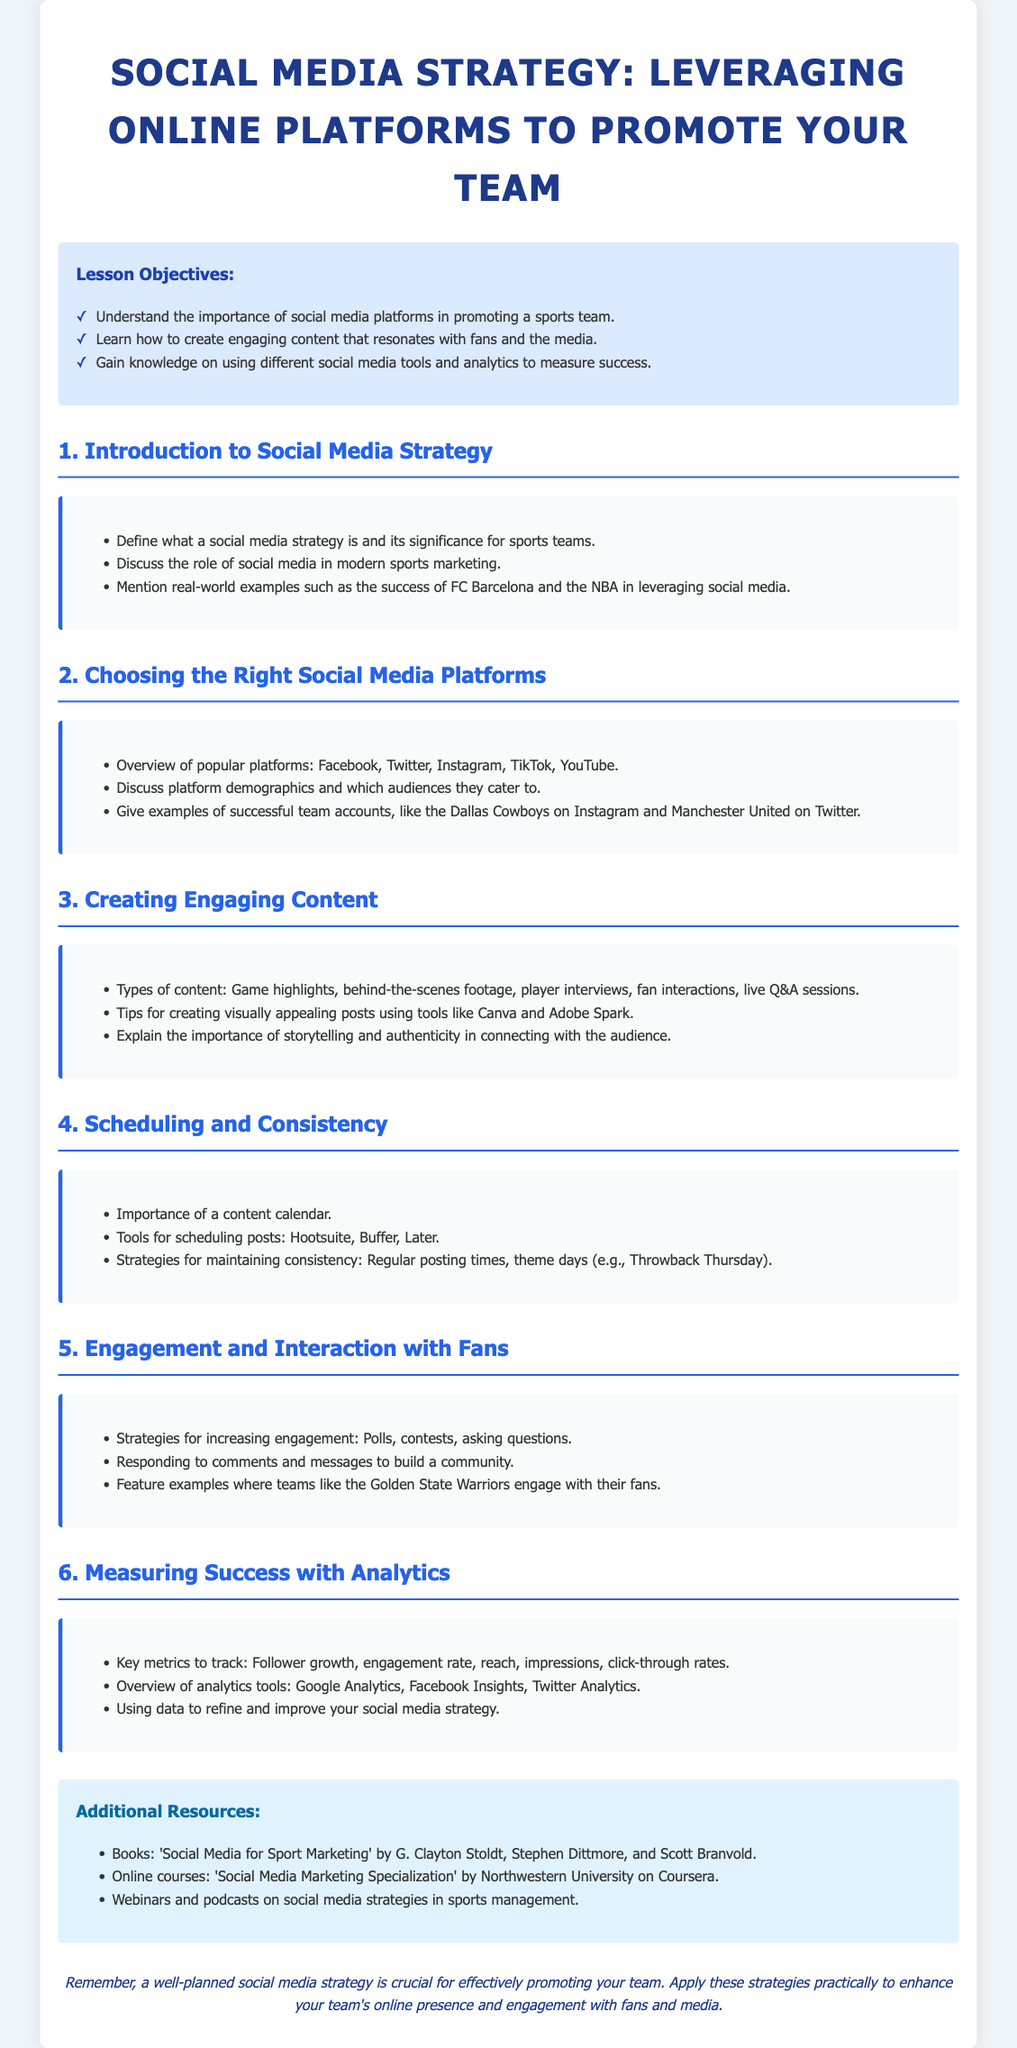what is the title of the document? The title appears at the top of the document, indicating the main topic it covers.
Answer: Social Media Strategy: Leveraging Online Platforms to Promote Your Team how many objectives are listed in the lesson? The objectives are found in the section titled "Lesson Objectives," where they are enumerated.
Answer: 3 which platform is mentioned first in choosing the right social media platforms? The document lists popular platforms in a specific order in the relevant section.
Answer: Facebook what type of content is suggested for creating engaging posts? The lesson provides examples of content types in the section on creating engaging content.
Answer: Game highlights which tool is recommended for scheduling posts? The document mentions specific tools in the section regarding scheduling and consistency.
Answer: Hootsuite what is a key metric suggested for measuring success? Key metrics are listed in the section about measuring success with analytics.
Answer: Engagement rate how many sections are in the lesson plan? By counting the main headings in the document, you can determine the total number of sections.
Answer: 6 who are the authors of the recommended book resource? The document provides information about a recommended book in the additional resources section.
Answer: G. Clayton Stoldt, Stephen Dittmore, and Scott Branvold what is the color of the container background? The document describes the styling of the container, including its background color.
Answer: White 